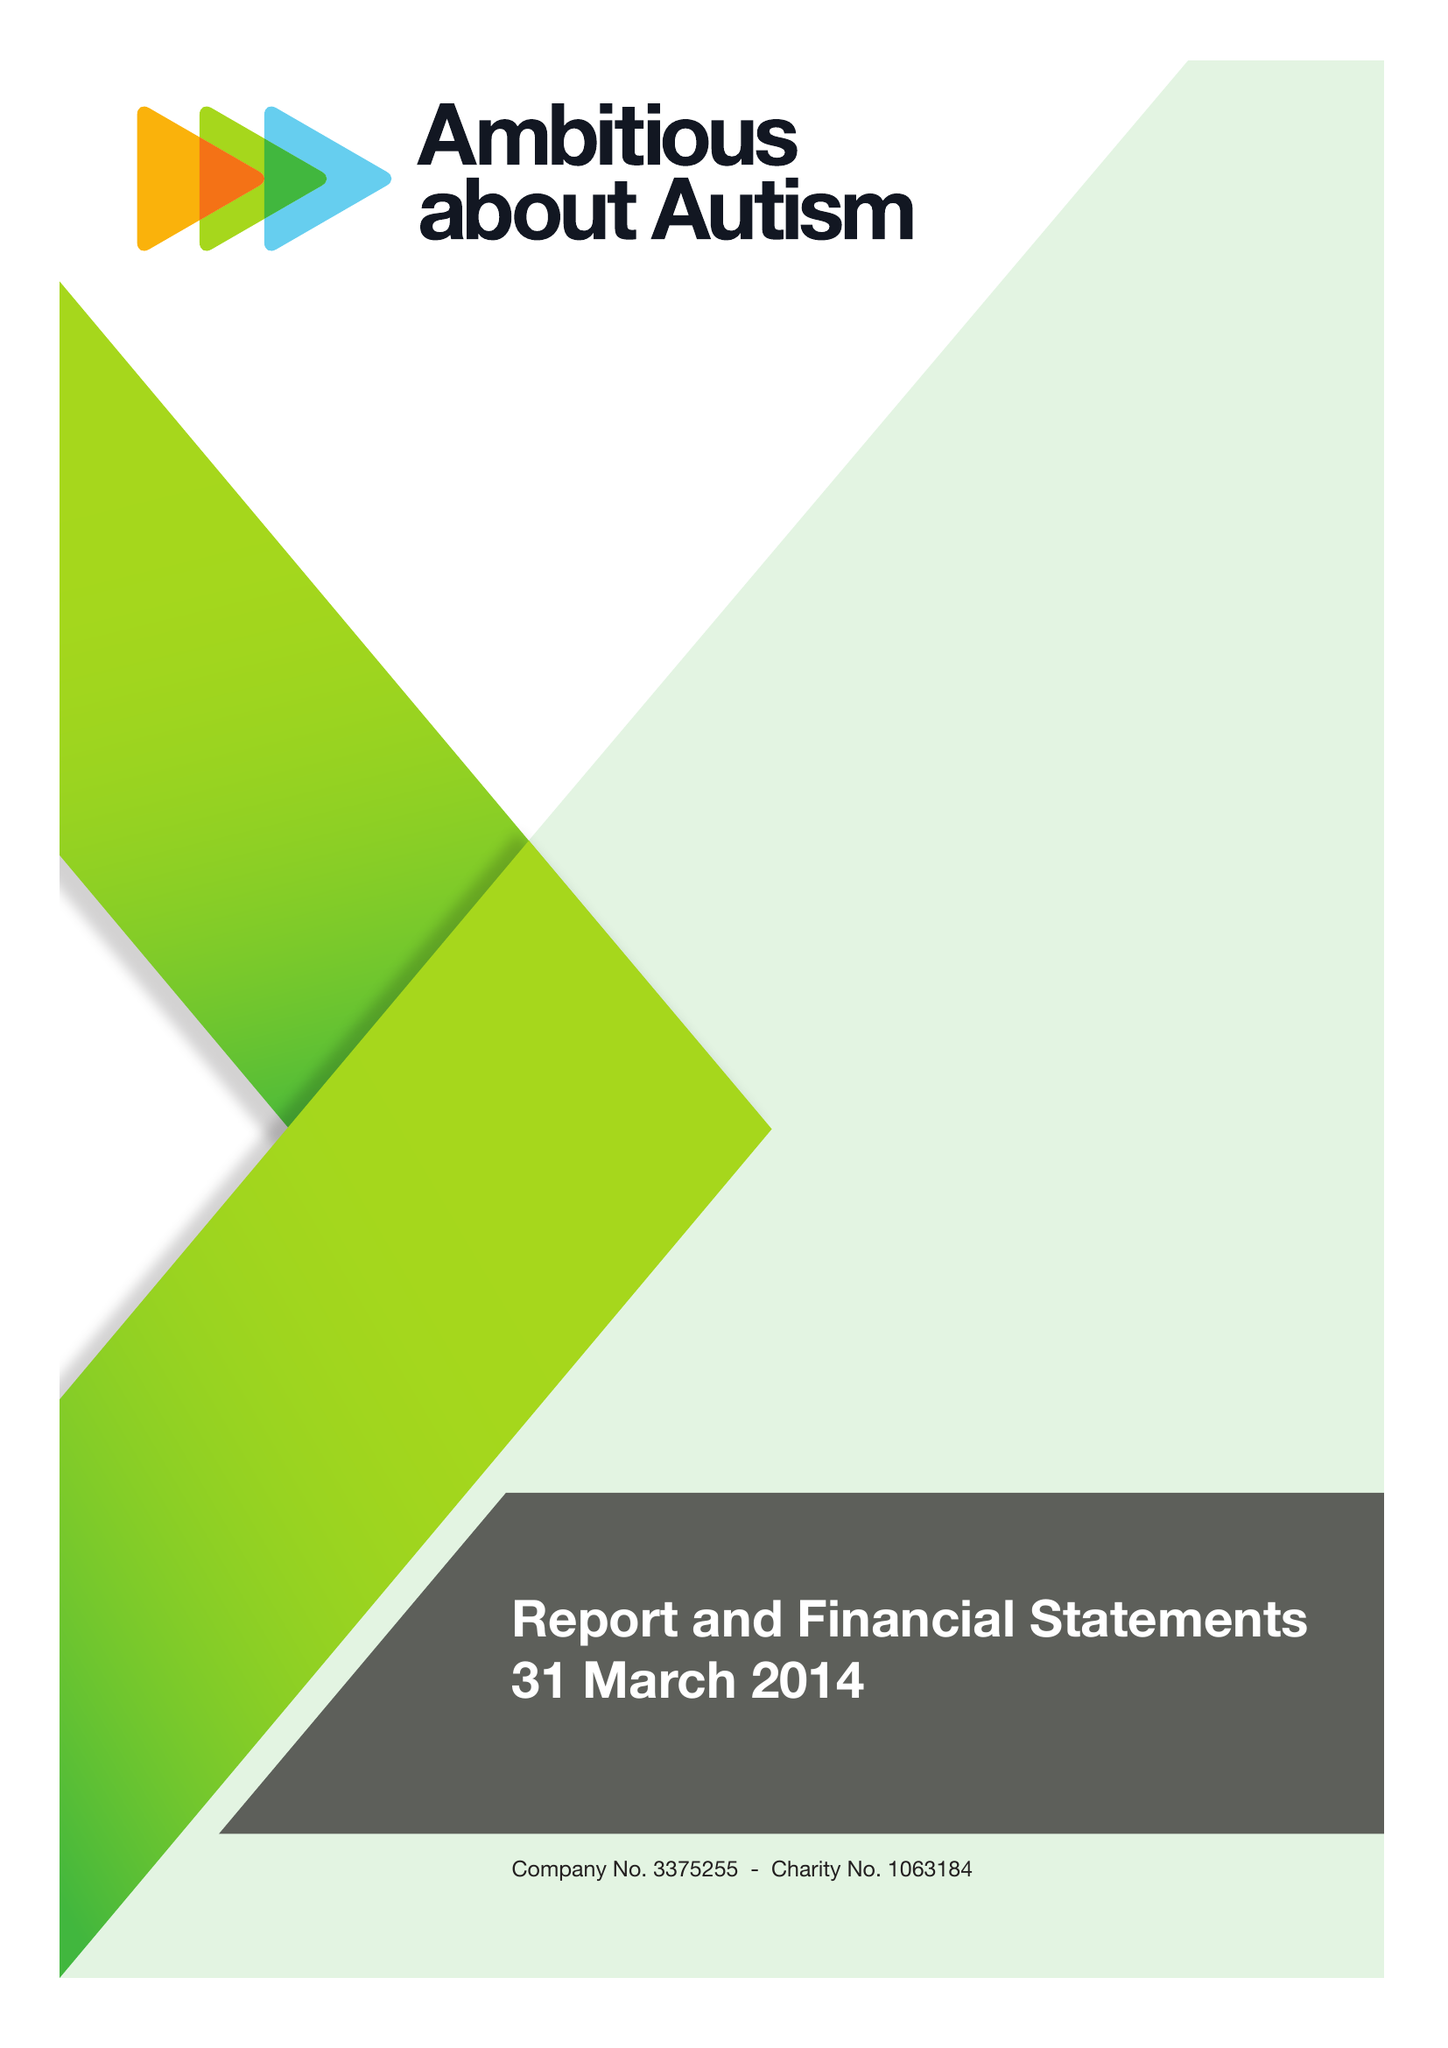What is the value for the spending_annually_in_british_pounds?
Answer the question using a single word or phrase. 8975800.00 